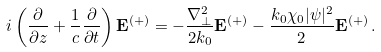Convert formula to latex. <formula><loc_0><loc_0><loc_500><loc_500>i \left ( \frac { \partial } { \partial z } + \frac { 1 } { c } \frac { \partial } { \partial t } \right ) { \mathbf E } ^ { ( + ) } = - \frac { \nabla ^ { 2 } _ { \perp } } { 2 k _ { 0 } } { \mathbf E } ^ { ( + ) } - \frac { k _ { 0 } \chi _ { 0 } | \psi | ^ { 2 } } { 2 } { \mathbf E } ^ { ( + ) } \, .</formula> 